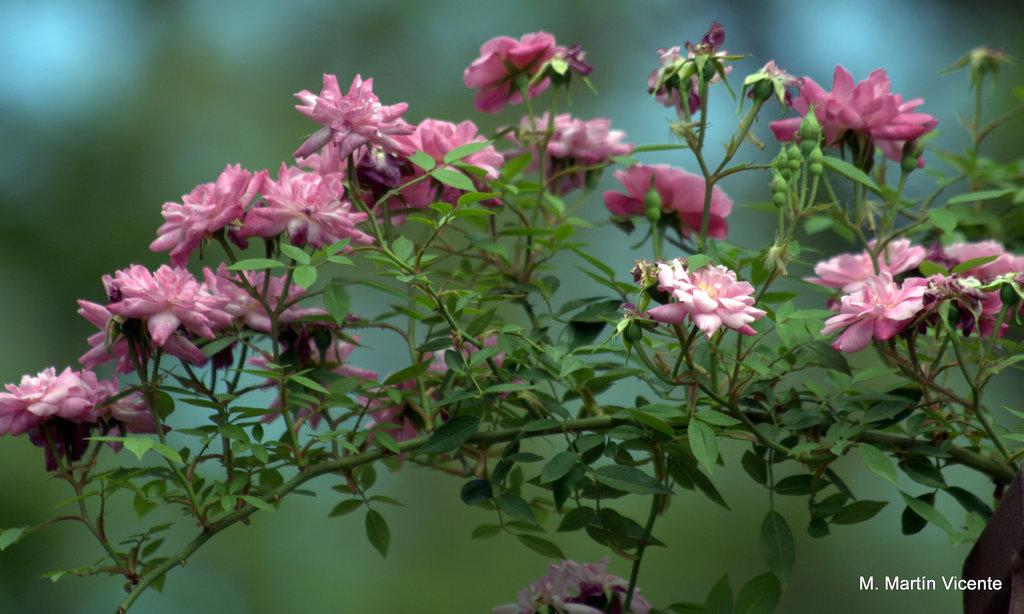What type of plants can be seen in the image? There are plants with flowers in the image. What color are the flowers on the plants? The flowers are pink in color. Can you describe the plants behind the flowers? The plants behind the flowers are not clearly visible, so it is difficult to describe them. What word is written on the thumb of the person holding the flowers in the image? There is no person holding the flowers in the image, and therefore no thumb or word written on it. 